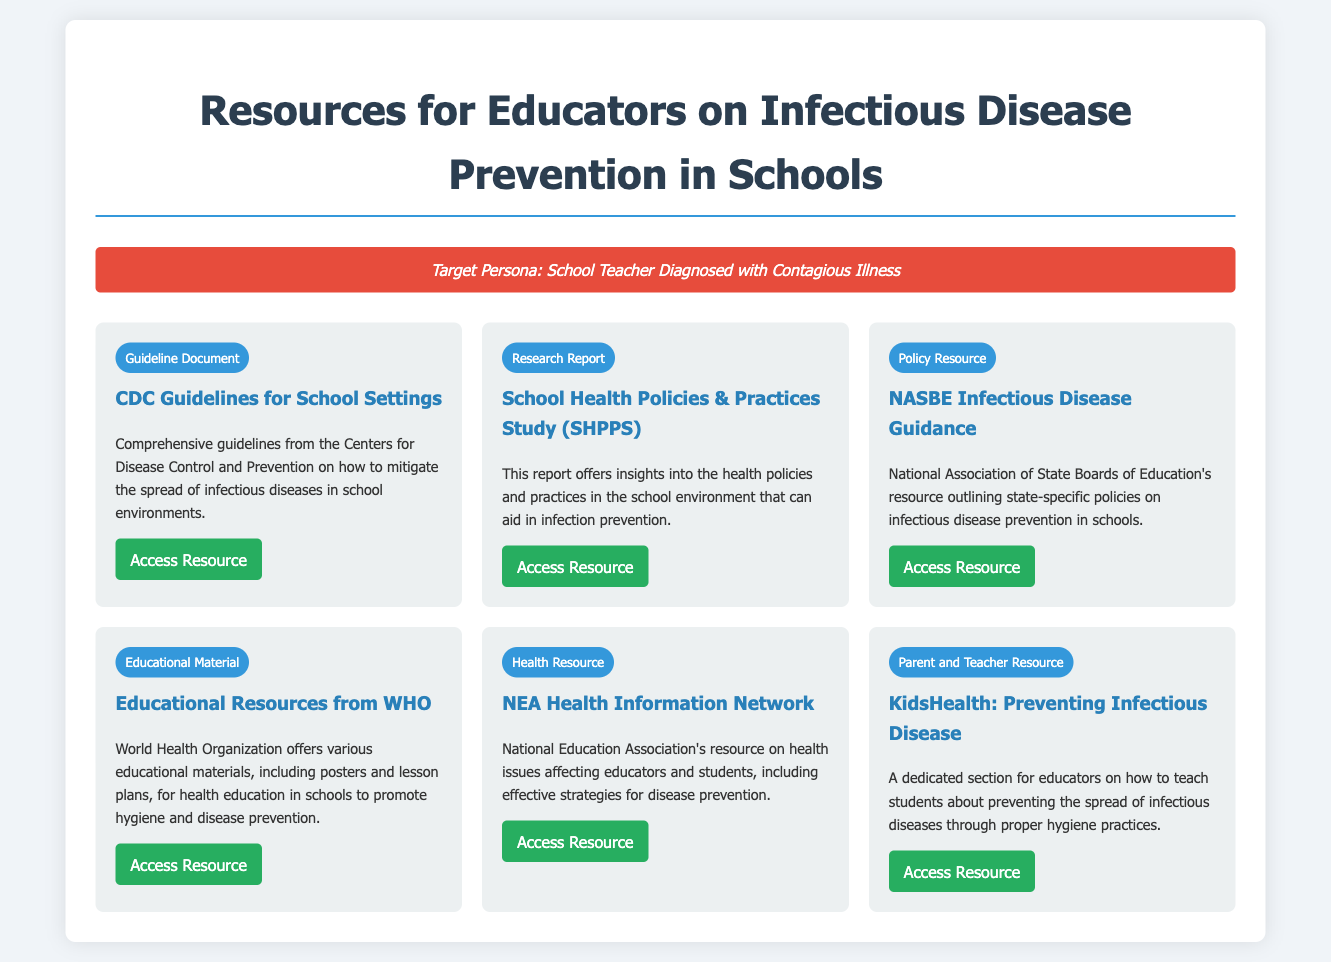what is the title of the document? The title is prominently displayed at the top of the document, summarizing the content.
Answer: Resources for Educators on Infectious Disease Prevention in Schools how many types of resources are listed? The document describes various types of resources for educators, which can be counted.
Answer: 6 what organization provided the guidelines for school settings? The source of the guidelines is mentioned in the resource section.
Answer: CDC which resource offers educational materials from WHO? This specific resource is highlighted for its educational content related to hygiene and disease prevention.
Answer: Educational Resources from WHO what is the focus of the KidsHealth resource? The description of the resource indicates its target audience and educational purpose.
Answer: Preventing Infectious Disease which organization is associated with health issues affecting educators? The health resource in the document references a specific national educational association.
Answer: NEA 